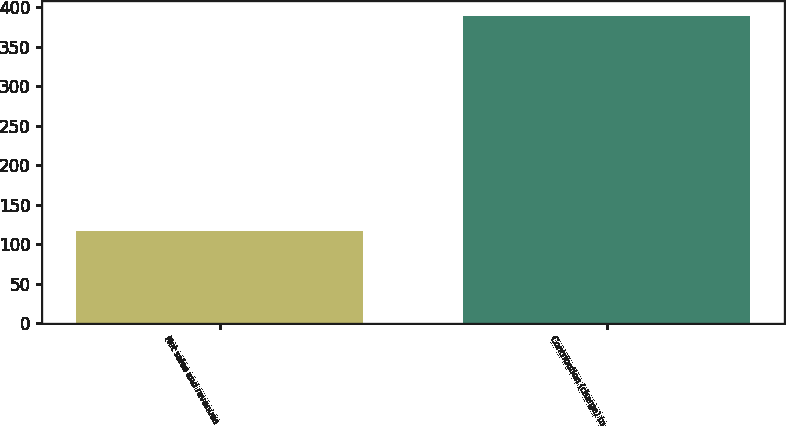<chart> <loc_0><loc_0><loc_500><loc_500><bar_chart><fcel>Net sales and revenues<fcel>Contribution (charge) to<nl><fcel>116<fcel>389<nl></chart> 